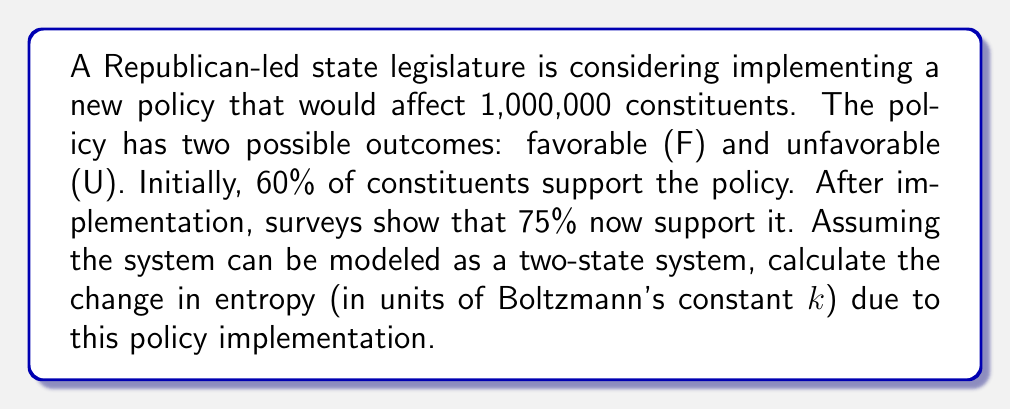Can you solve this math problem? To solve this problem, we'll use the formula for entropy in a two-state system and calculate the change:

1) The entropy of a two-state system is given by:
   $$S = -k[p_F \ln(p_F) + p_U \ln(p_U)]$$
   where $k$ is Boltzmann's constant, $p_F$ is the probability of the favorable state, and $p_U$ is the probability of the unfavorable state.

2) Initial state:
   $p_F = 0.60$, $p_U = 0.40$
   $$S_i = -k[0.60 \ln(0.60) + 0.40 \ln(0.40)]$$

3) Final state:
   $p_F = 0.75$, $p_U = 0.25$
   $$S_f = -k[0.75 \ln(0.75) + 0.25 \ln(0.25)]$$

4) Calculate each entropy:
   $$S_i = -k[-0.30667 - 0.36651] = 0.67318k$$
   $$S_f = -k[-0.21576 - 0.34657] = 0.56233k$$

5) Calculate the change in entropy:
   $$\Delta S = S_f - S_i = 0.56233k - 0.67318k = -0.11085k$$

The negative value indicates a decrease in entropy, suggesting the system became more ordered (less uncertain) after policy implementation.
Answer: $-0.11085k$ 